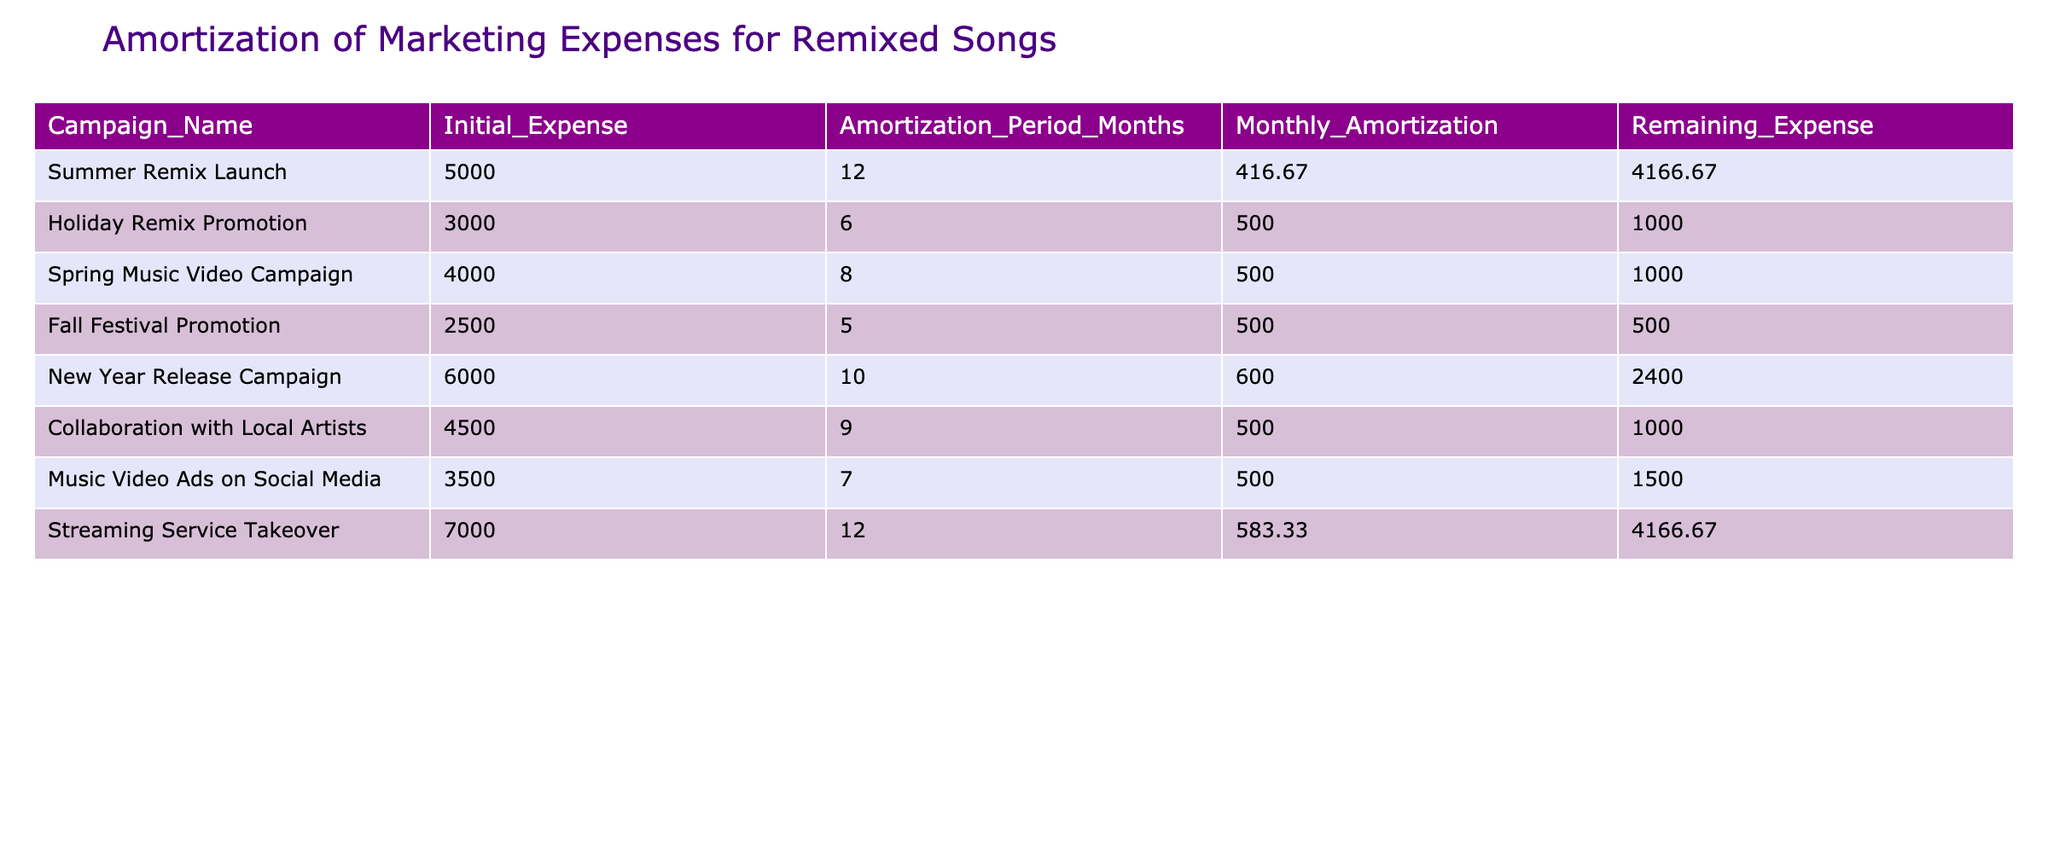What is the initial expense for the "Holiday Remix Promotion"? The table lists the "Initial_Expense" column. For "Holiday Remix Promotion," the initial expense is specified as 3000.
Answer: 3000 What is the monthly amortization for the "New Year Release Campaign"? In the table, the "Monthly_Amortization" for the "New Year Release Campaign" is shown as 600.
Answer: 600 Which campaign has the longest amortization period? To answer, we can look at the "Amortization_Period_Months" column. The "Summer Remix Launch" has the longest period at 12 months.
Answer: Summer Remix Launch What is the total initial expense for all campaigns? Summing the "Initial_Expense" values, we have: 5000 + 3000 + 4000 + 2500 + 6000 + 4500 + 3500 + 7000 = 31500.
Answer: 31500 Does the "Fall Festival Promotion" have a remaining expense of 500? The table indicates that the "Remaining_Expense" for "Fall Festival Promotion" is indeed 500, so this statement is true.
Answer: Yes What is the average monthly amortization across all campaigns? To find the average, we sum the "Monthly_Amortization" values: (416.67 + 500 + 500 + 500 + 600 + 500 + 500 + 583.33) = 4100, and then divide by the total number of campaigns, which is 8. Thus, the average is 4100/8 = 512.5.
Answer: 512.5 Which campaign has the least remaining expense? By comparing the "Remaining_Expense" values, we find that "Fall Festival Promotion" has the least remaining expense at 500, followed closely by "Holiday Remix Promotion" at 1000.
Answer: Fall Festival Promotion What is the total remaining expense for campaigns with an amortization period of 10 months or longer? From the table, the campaigns with at least 10 months are "Summer Remix Launch" and "Streaming Service Takeover," with remaining expenses of 4166.67 and 4166.67 respectively. Adding these gives us 4166.67 + 4166.67 = 8333.34.
Answer: 8333.34 Is the monthly amortization for the "Collaboration with Local Artists" higher than 500? The table indicates that the monthly amortization for "Collaboration with Local Artists" is 500, thus it is not higher than 500; therefore, this statement is false.
Answer: No 